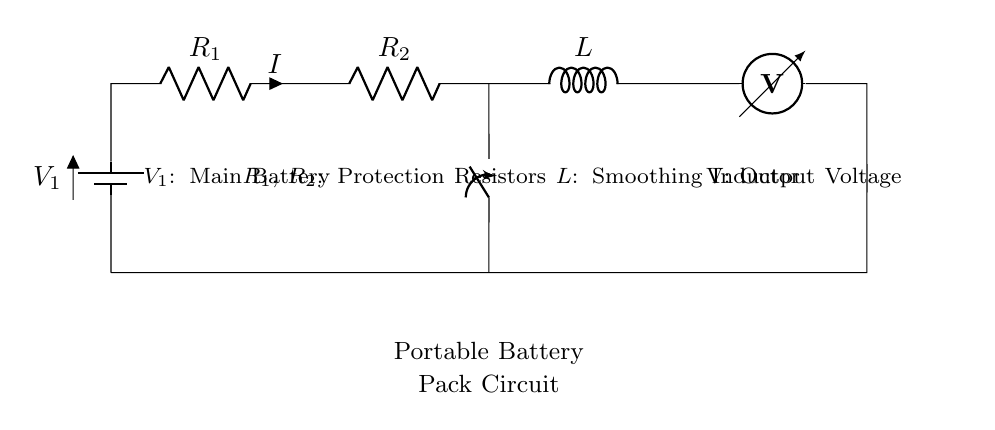What is the main battery in this circuit? The main battery is labeled as V1 in the circuit diagram, which is prominently located at the left side of the circuit.
Answer: V1 What do R1 and R2 represent? R1 and R2 are labeled as protection resistors in the circuit diagram, indicating their role in limiting current and protecting the circuit components.
Answer: Protection Resistors How many resistors are in series in this portable battery pack circuit? There are two resistors, R1 and R2, shown in a series configuration as they are part of the same branch of the circuit connecting from the battery toward the output.
Answer: Two What is the function of the inductor L in this circuit? The inductor L is labeled as a smoothing inductor, which means it helps to reduce voltage fluctuations and smooth out the output voltage for stable charging.
Answer: Smoothing Inductor If the circuit were to be opened by the switch, what happens to the current I? With the switch open, the complete circuit path is broken, and as a result, the current I would drop to zero since there's no path for current flow.
Answer: Zero What type of circuit is represented in this diagram? The circuit represented is a series circuit as all components, including the battery, resistors, and inductor, are connected in a single path for current to flow.
Answer: Series Circuit What is measured at the voltmeter in this circuit? The voltmeter measures the output voltage V at the end of the circuit before returning to the battery, indicating the voltage available for charging the mobile devices.
Answer: Output Voltage 